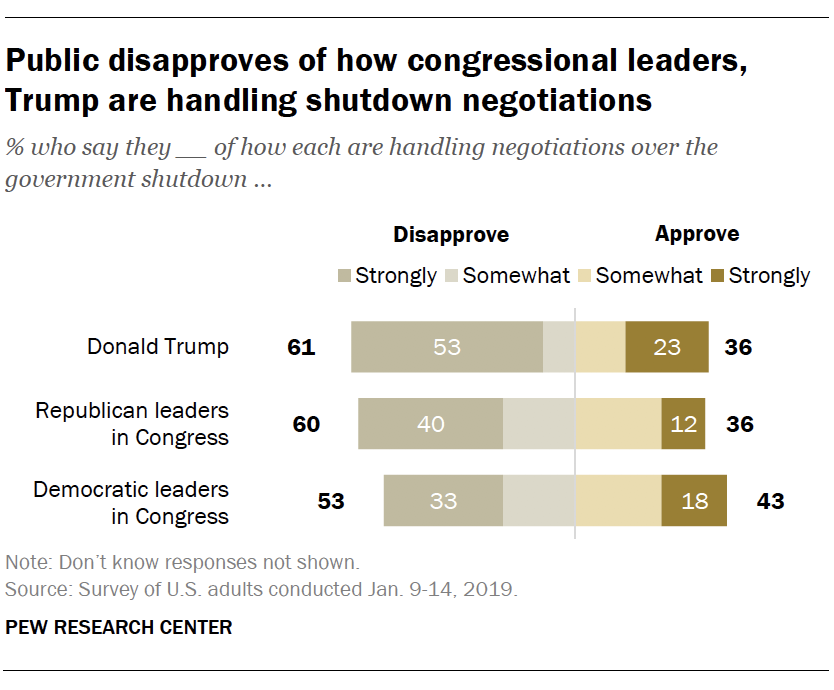Mention a couple of crucial points in this snapshot. The graph is represented using four colors. The answer to the question "Is the median of Strongly Approve bars greater than the median of Strongly Disapprove bars? No." can be stated as "The median of Strongly Approve bars is not greater than the median of Strongly Disapprove bars. 